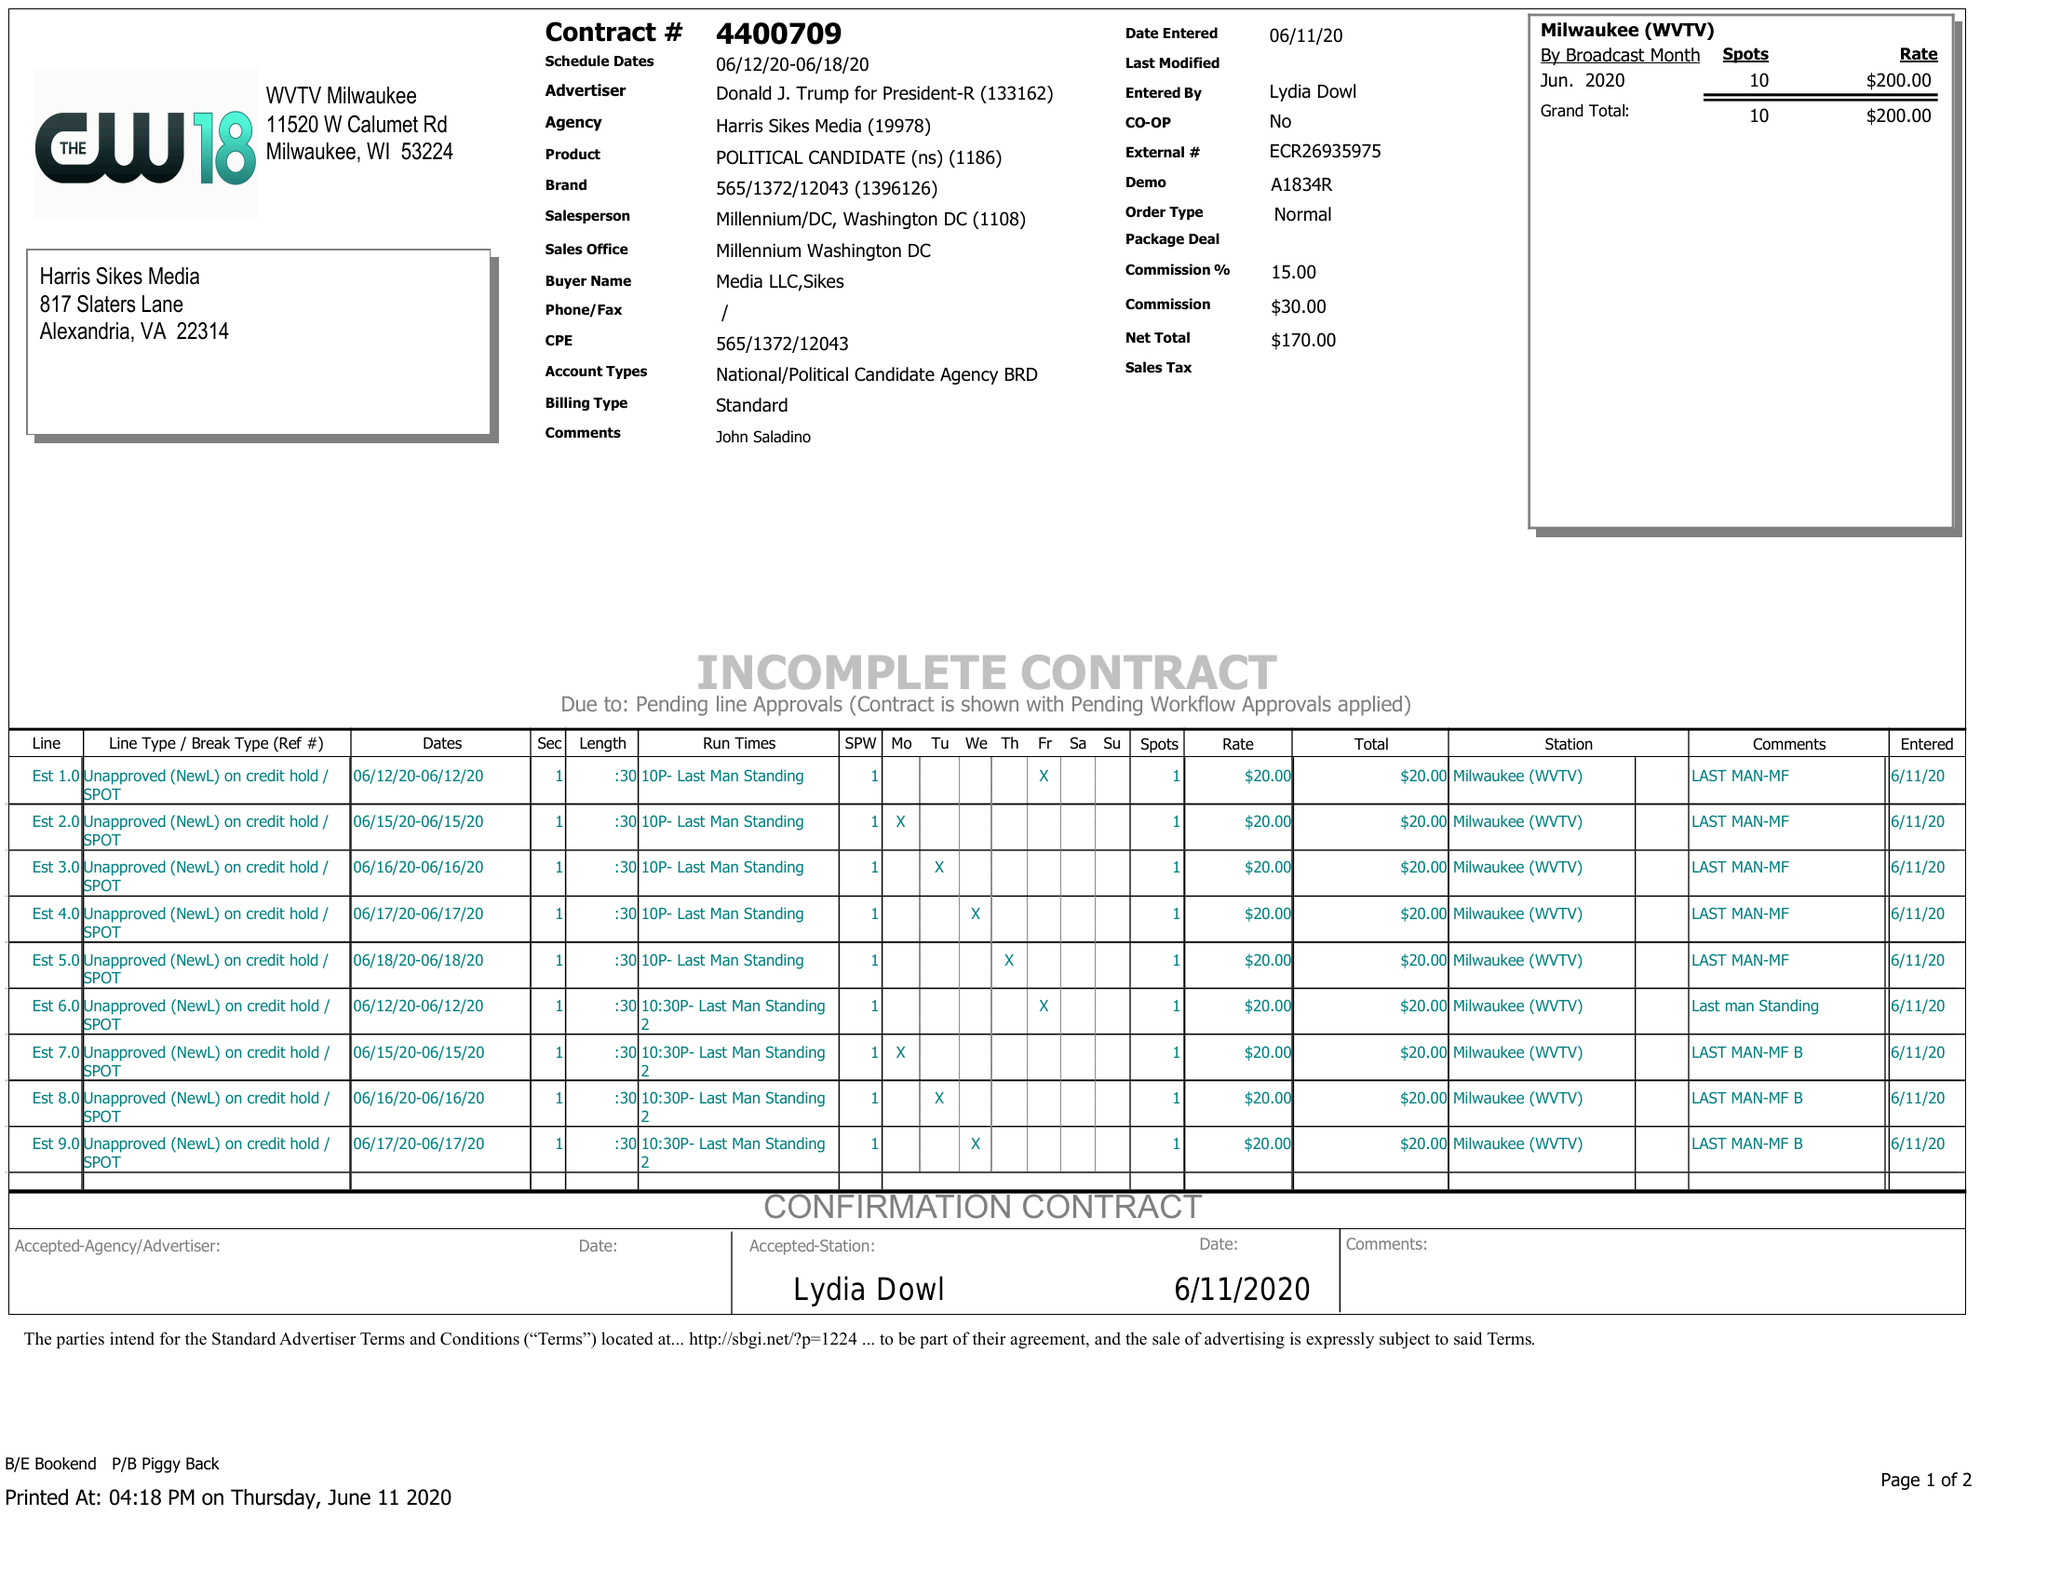What is the value for the gross_amount?
Answer the question using a single word or phrase. 200.00 